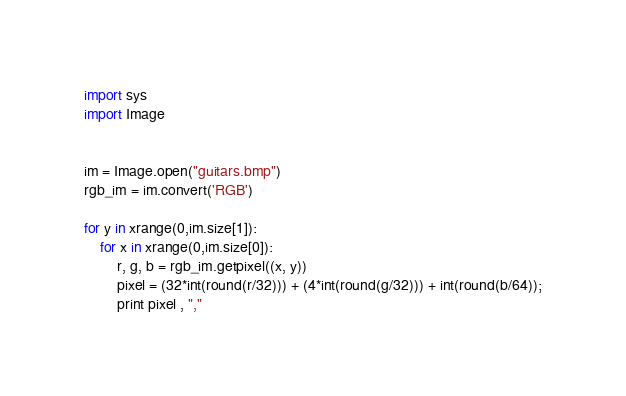<code> <loc_0><loc_0><loc_500><loc_500><_Python_>import sys
import Image


im = Image.open("guitars.bmp")
rgb_im = im.convert('RGB')

for y in xrange(0,im.size[1]):
	for x in xrange(0,im.size[0]):
		r, g, b = rgb_im.getpixel((x, y))
		pixel = (32*int(round(r/32))) + (4*int(round(g/32))) + int(round(b/64));
		print pixel , ","

</code> 